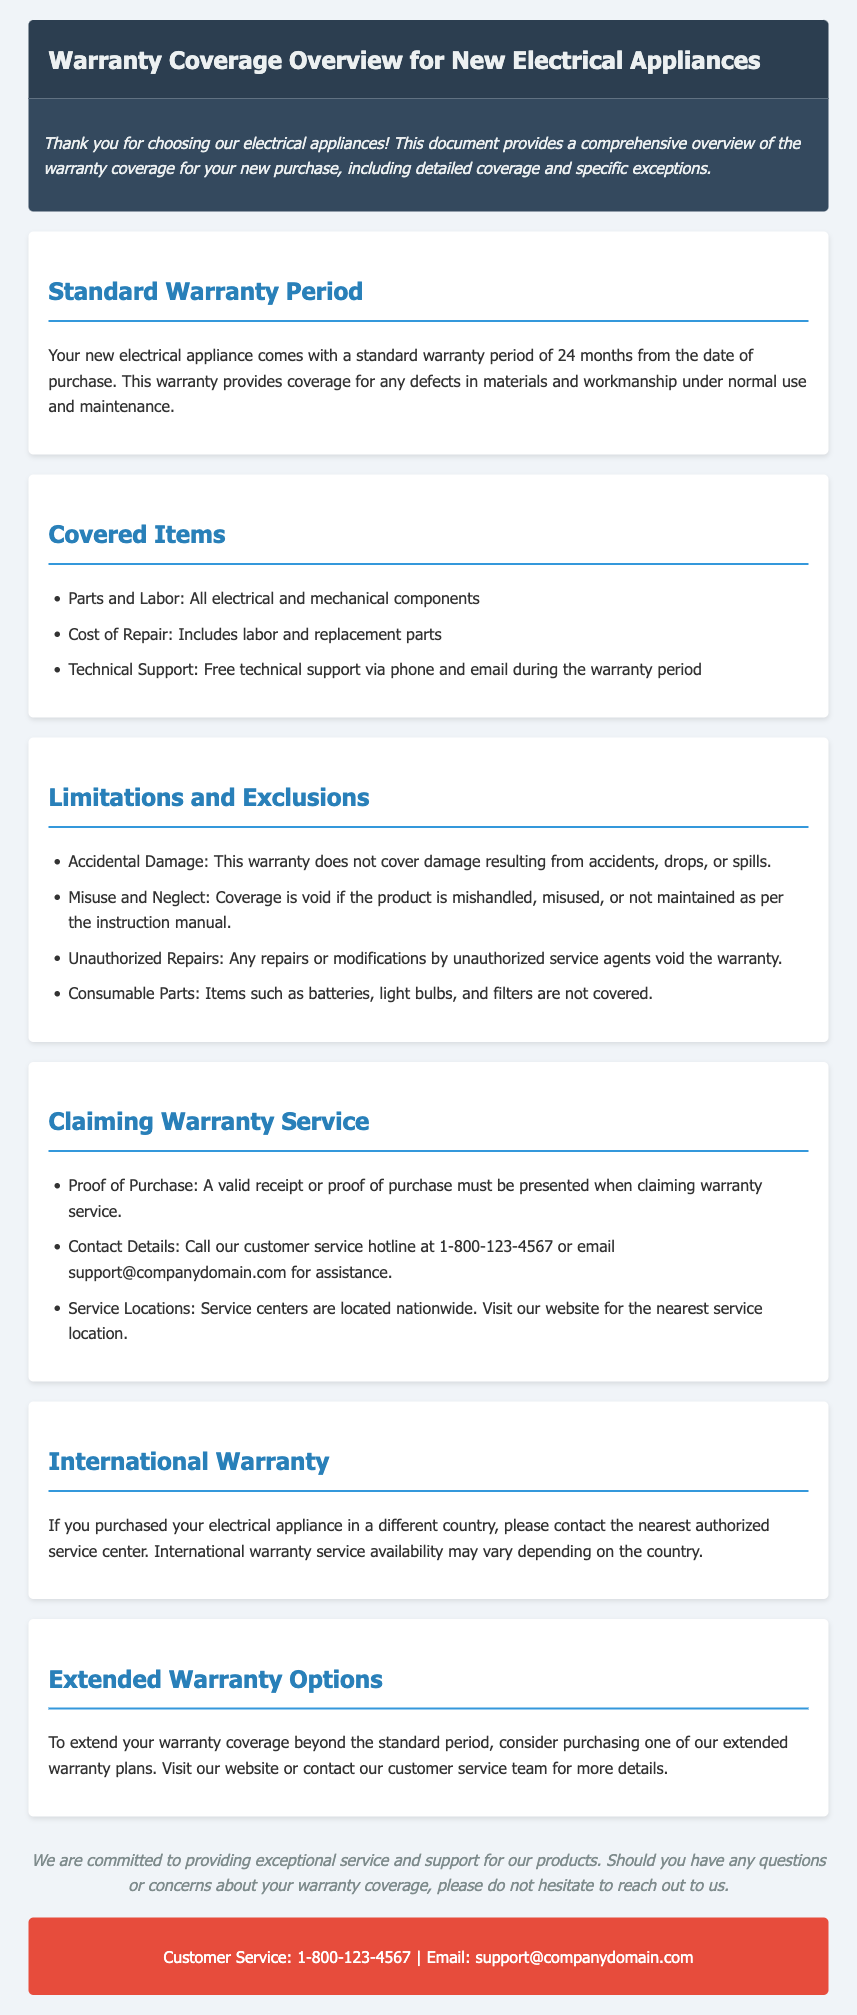What is the standard warranty period for new appliances? The document states that the standard warranty period is 24 months from the date of purchase.
Answer: 24 months What is covered under the warranty? The document lists parts and labor, cost of repair, and technical support as covered items.
Answer: Parts and Labor; Cost of Repair; Technical Support What type of damage is not covered by the warranty? The document specifies that accidental damage is not covered.
Answer: Accidental Damage What must be presented to claim warranty service? According to the document, a valid receipt or proof of purchase must be presented.
Answer: Valid receipt or proof of purchase What is the customer service hotline number? The document provides a customer service hotline number for assistance during warranty claims.
Answer: 1-800-123-4567 What should you do if you purchased the appliance in another country? The document advises to contact the nearest authorized service center for international warranty inquiries.
Answer: Contact the nearest authorized service center Are consumable parts covered under the warranty? The document explicitly states that consumable parts are not covered.
Answer: No What options are available for extending warranty coverage? The document suggests purchasing one of the extended warranty plans.
Answer: Extended warranty plans 